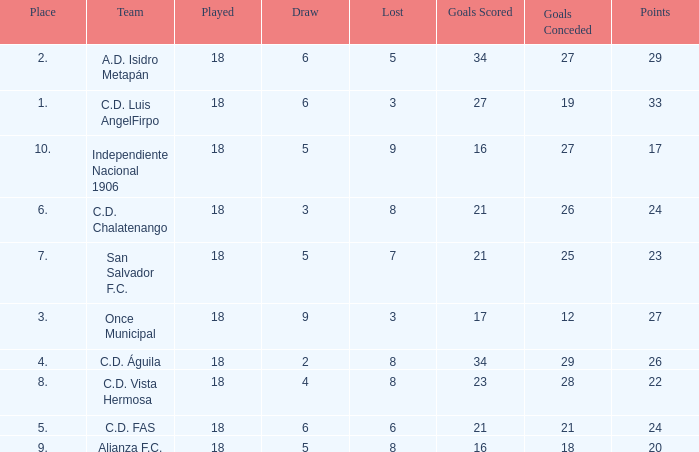Can you give me this table as a dict? {'header': ['Place', 'Team', 'Played', 'Draw', 'Lost', 'Goals Scored', 'Goals Conceded', 'Points'], 'rows': [['2.', 'A.D. Isidro Metapán', '18', '6', '5', '34', '27', '29'], ['1.', 'C.D. Luis AngelFirpo', '18', '6', '3', '27', '19', '33'], ['10.', 'Independiente Nacional 1906', '18', '5', '9', '16', '27', '17'], ['6.', 'C.D. Chalatenango', '18', '3', '8', '21', '26', '24'], ['7.', 'San Salvador F.C.', '18', '5', '7', '21', '25', '23'], ['3.', 'Once Municipal', '18', '9', '3', '17', '12', '27'], ['4.', 'C.D. Águila', '18', '2', '8', '34', '29', '26'], ['8.', 'C.D. Vista Hermosa', '18', '4', '8', '23', '28', '22'], ['5.', 'C.D. FAS', '18', '6', '6', '21', '21', '24'], ['9.', 'Alianza F.C.', '18', '5', '8', '16', '18', '20']]} For Once Municipal, what were the goals scored that had less than 27 points and greater than place 1? None. 